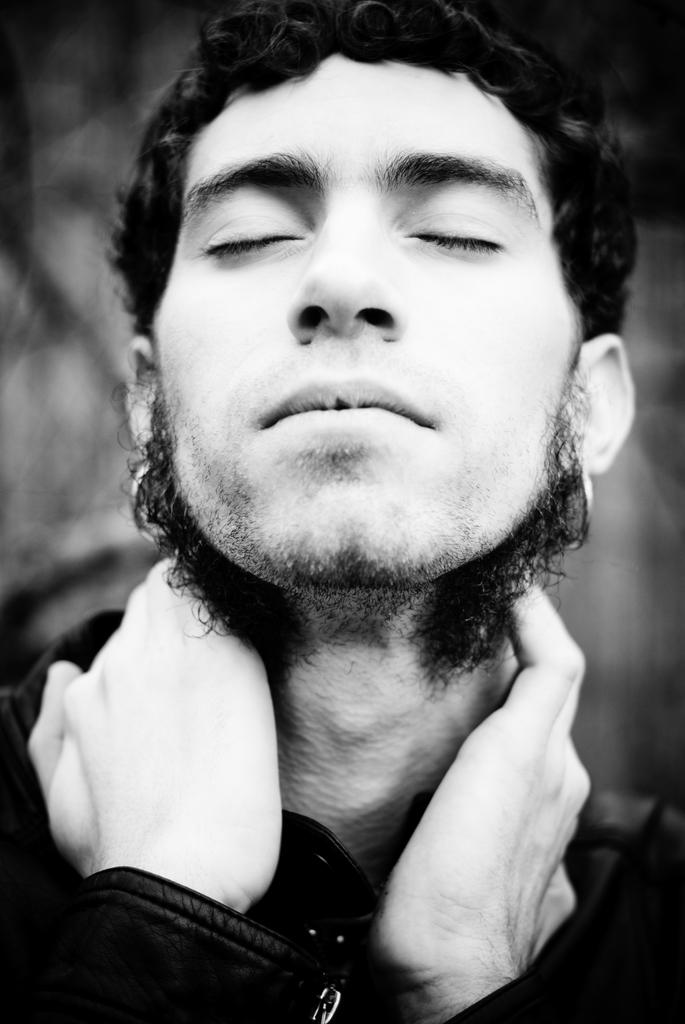What is the main subject of the image? There is a close-up picture of a man in the image. What can be seen on the man in the image? The man is wearing clothes. How would you describe the background of the image? The background of the image is blurred. What type of needle is the man holding in the image? There is no needle present in the image. What shape is the man's face in the image? The image is a close-up of the man, so it does not show the shape of his face. 